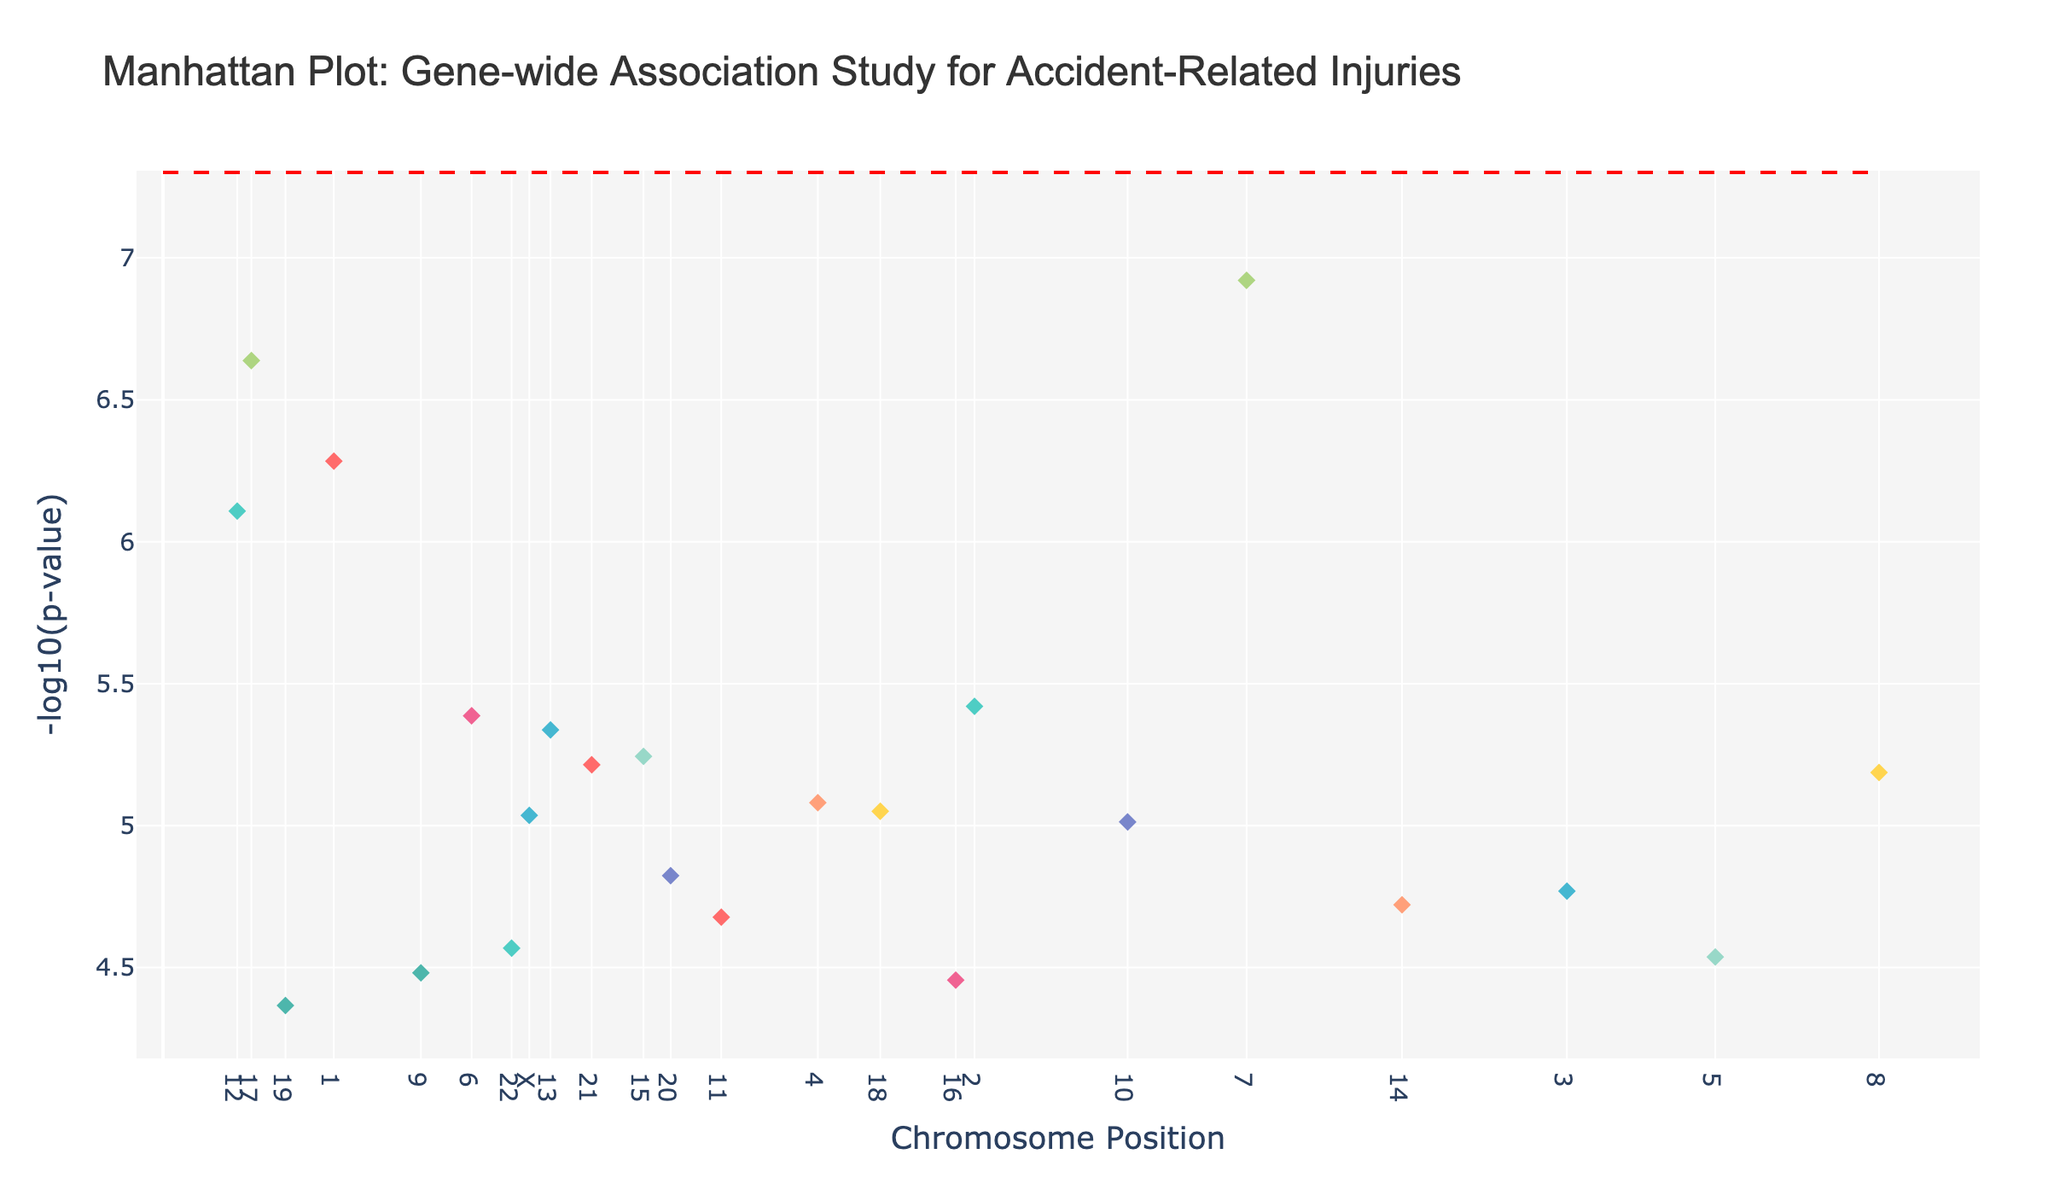What's the main title of the plot? The title is located at the top of the plot and generally describes the main focus or subject of the chart. Here, it reads 'Manhattan Plot: Gene-wide Association Study for Accident-Related Injuries'
Answer: Manhattan Plot: Gene-wide Association Study for Accident-Related Injuries What does the y-axis represent? The label of the y-axis can be found on the left side of the plot, indicating the metric being measured. It shows '-log10(p-value)', which helps in identifying significant p-values.
Answer: -log10(p-value) Which chromosome has the highest point in terms of -log10(p-value)? By examining the highest point on the y-axis and tracing it back to the corresponding chromosome, we can see that Chromosome 7 has the highest data point.
Answer: Chromosome 7 How many chromosomes are included in this plot? The x-axis has tick marks representing each chromosome. By counting these ticks, we can determine the number of chromosomes plotted. In total, the plot includes chromosomes 1 through 22 and the X chromosome.
Answer: 23 Which gene has the lowest p-value in this study? The gene with the lowest p-value corresponds to the highest point on the y-axis. According to the plot, this gene is COL1A2 on Chromosome 7.
Answer: COL1A2 What is the threshold p-value indicated by the red dashed line on the plot? The significance threshold is represented by the horizontal red dashed line. This line, labeled alongside the y-axis, usually stands at -log10(5e-8).
Answer: 5e-8 Compare the positions of genes TP53 and RUNX1. Which gene is located at a lower chromosome position? By observing the x-axis positions for TP53 (Chromosome 17) and RUNX1 (Chromosome 21), TP53 appears at a lower position (7.5 million) compared to RUNX1 (36.4 million).
Answer: TP53 Among BRCA2 and DDB2, which gene has a lower -log10(p-value)? The lower a point is on the y-axis, the lower its -log10(p-value). Here, BRCA2 on Chromosome 13 has a lower -log10(p-value) compared to DDB2 on Chromosome 11.
Answer: BRCA2 Which color is used to represent Chromosome 1 on the plot? Different chromosomes are represented by unique colors. Chromosome 1, having the PRDM16 gene, is marked in one specific color from the color map. Observing the plot reveals this color.
Answer: Red (or the specific color shown) What's the average -log10(p-value) of STAT1 and VWF genes? First, find the -log10(p-value) for STAT1 (3.8e-6 roughly 5.42) and VWF (7.8e-7 approximately 6.11). The average is calculated as (5.42 + 6.11) / 2 = 5.765
Answer: 5.765 